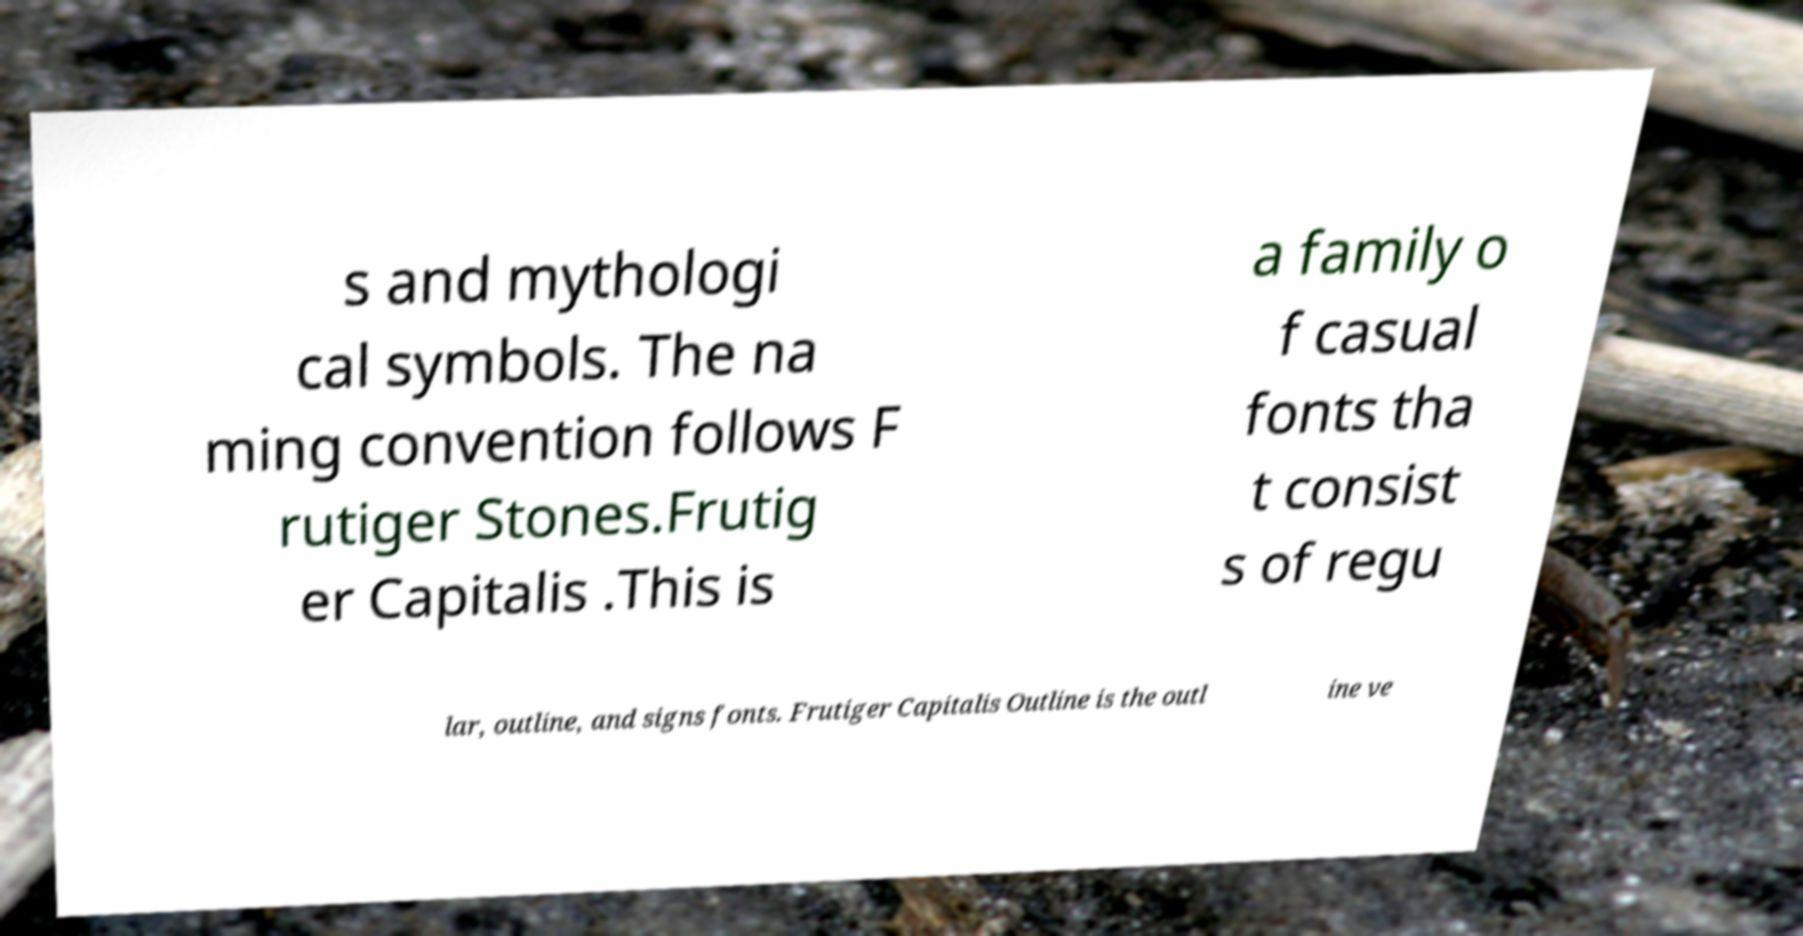Can you read and provide the text displayed in the image?This photo seems to have some interesting text. Can you extract and type it out for me? s and mythologi cal symbols. The na ming convention follows F rutiger Stones.Frutig er Capitalis .This is a family o f casual fonts tha t consist s of regu lar, outline, and signs fonts. Frutiger Capitalis Outline is the outl ine ve 